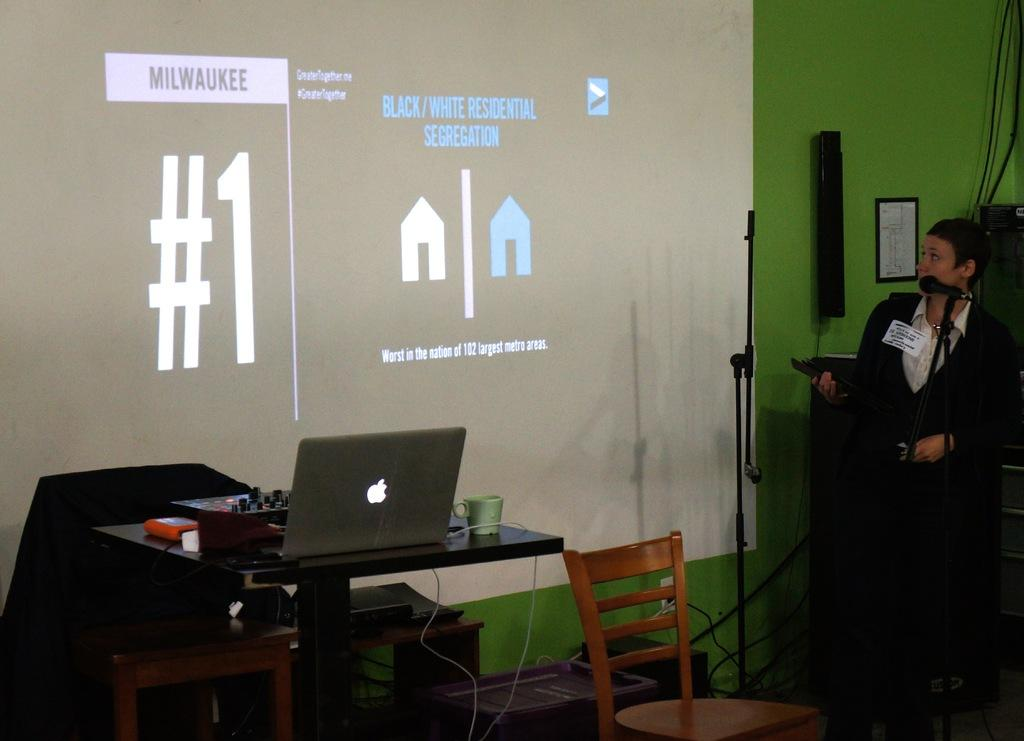What is the main feature of the image? There is a projected screen in the image. What is the man in the image doing? The man is standing and speaking in the image. How is the man's voice being amplified? The man is using a microphone. What device might be used to display the content on the projected screen? There is a laptop on a table in the image. What piece of furniture is present in the image? There is a chair in the image. Can you see any rice being cooked in the image? There is no rice or cooking activity present in the image. Is there a river visible in the background of the image? There is no river visible in the image; it primarily features a projected screen, a man speaking, and a laptop on a table. 